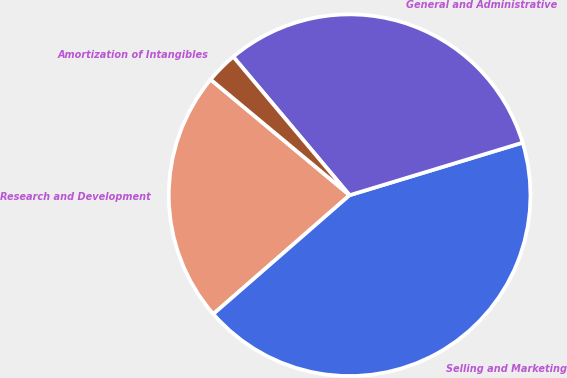<chart> <loc_0><loc_0><loc_500><loc_500><pie_chart><fcel>Research and Development<fcel>Selling and Marketing<fcel>General and Administrative<fcel>Amortization of Intangibles<nl><fcel>22.46%<fcel>43.28%<fcel>31.43%<fcel>2.83%<nl></chart> 